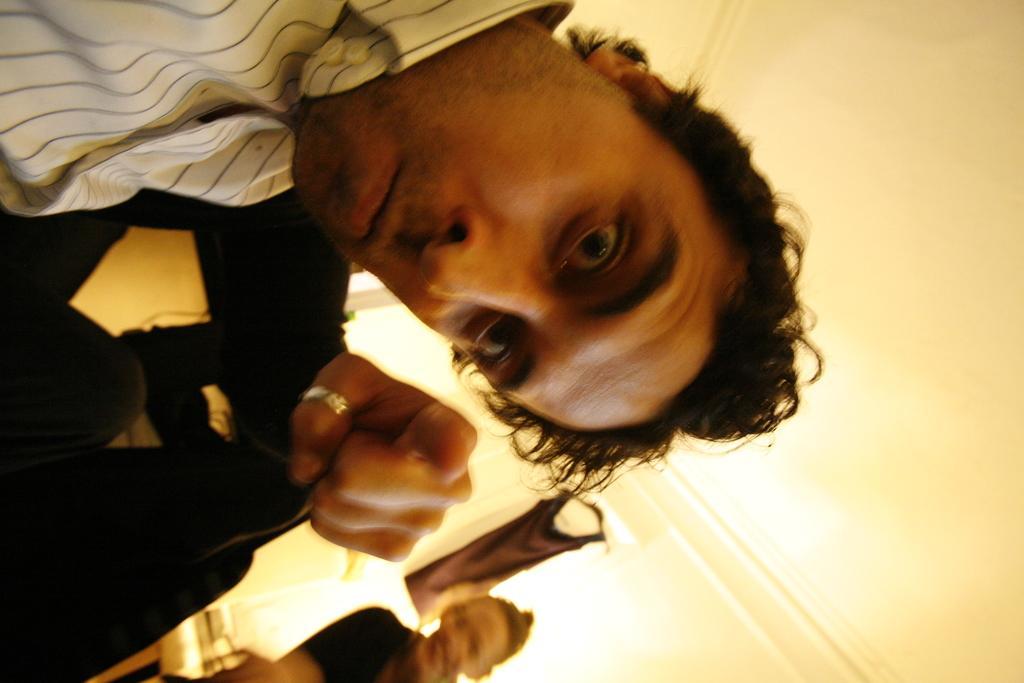Can you describe this image briefly? There are two people. In the background we can see chair and cloth hanging on a wall. 